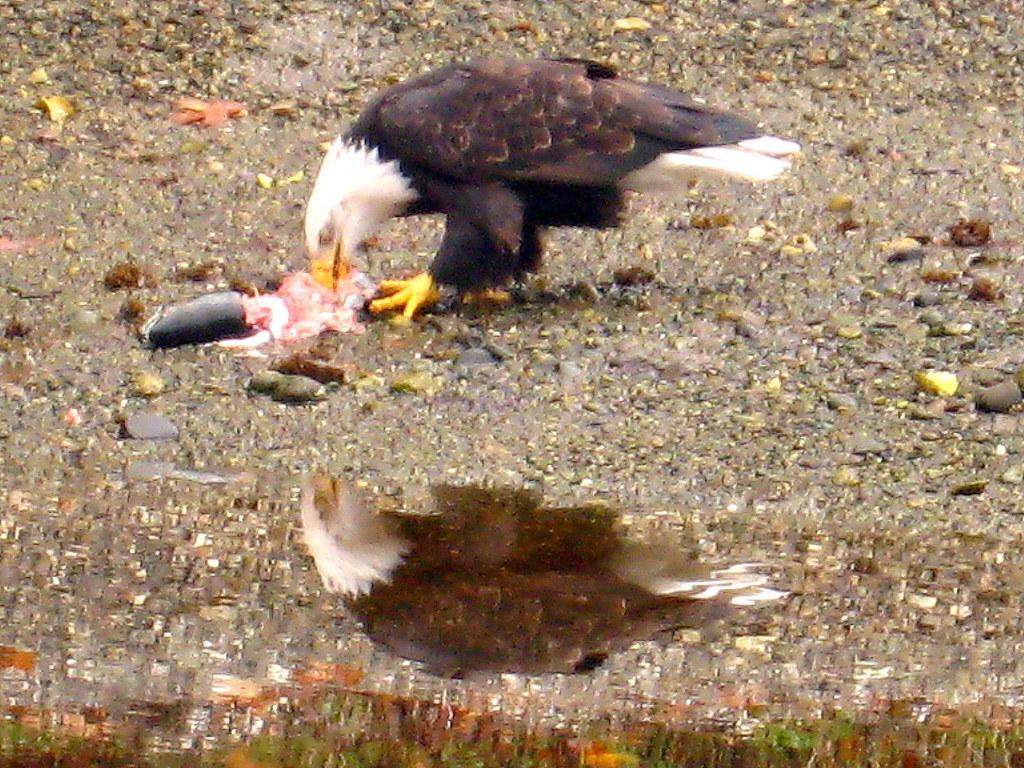Could you give a brief overview of what you see in this image? In this image I can see the bird which is in brown, black and white color. It is on the ground. To the side of the bird I can see the water. 